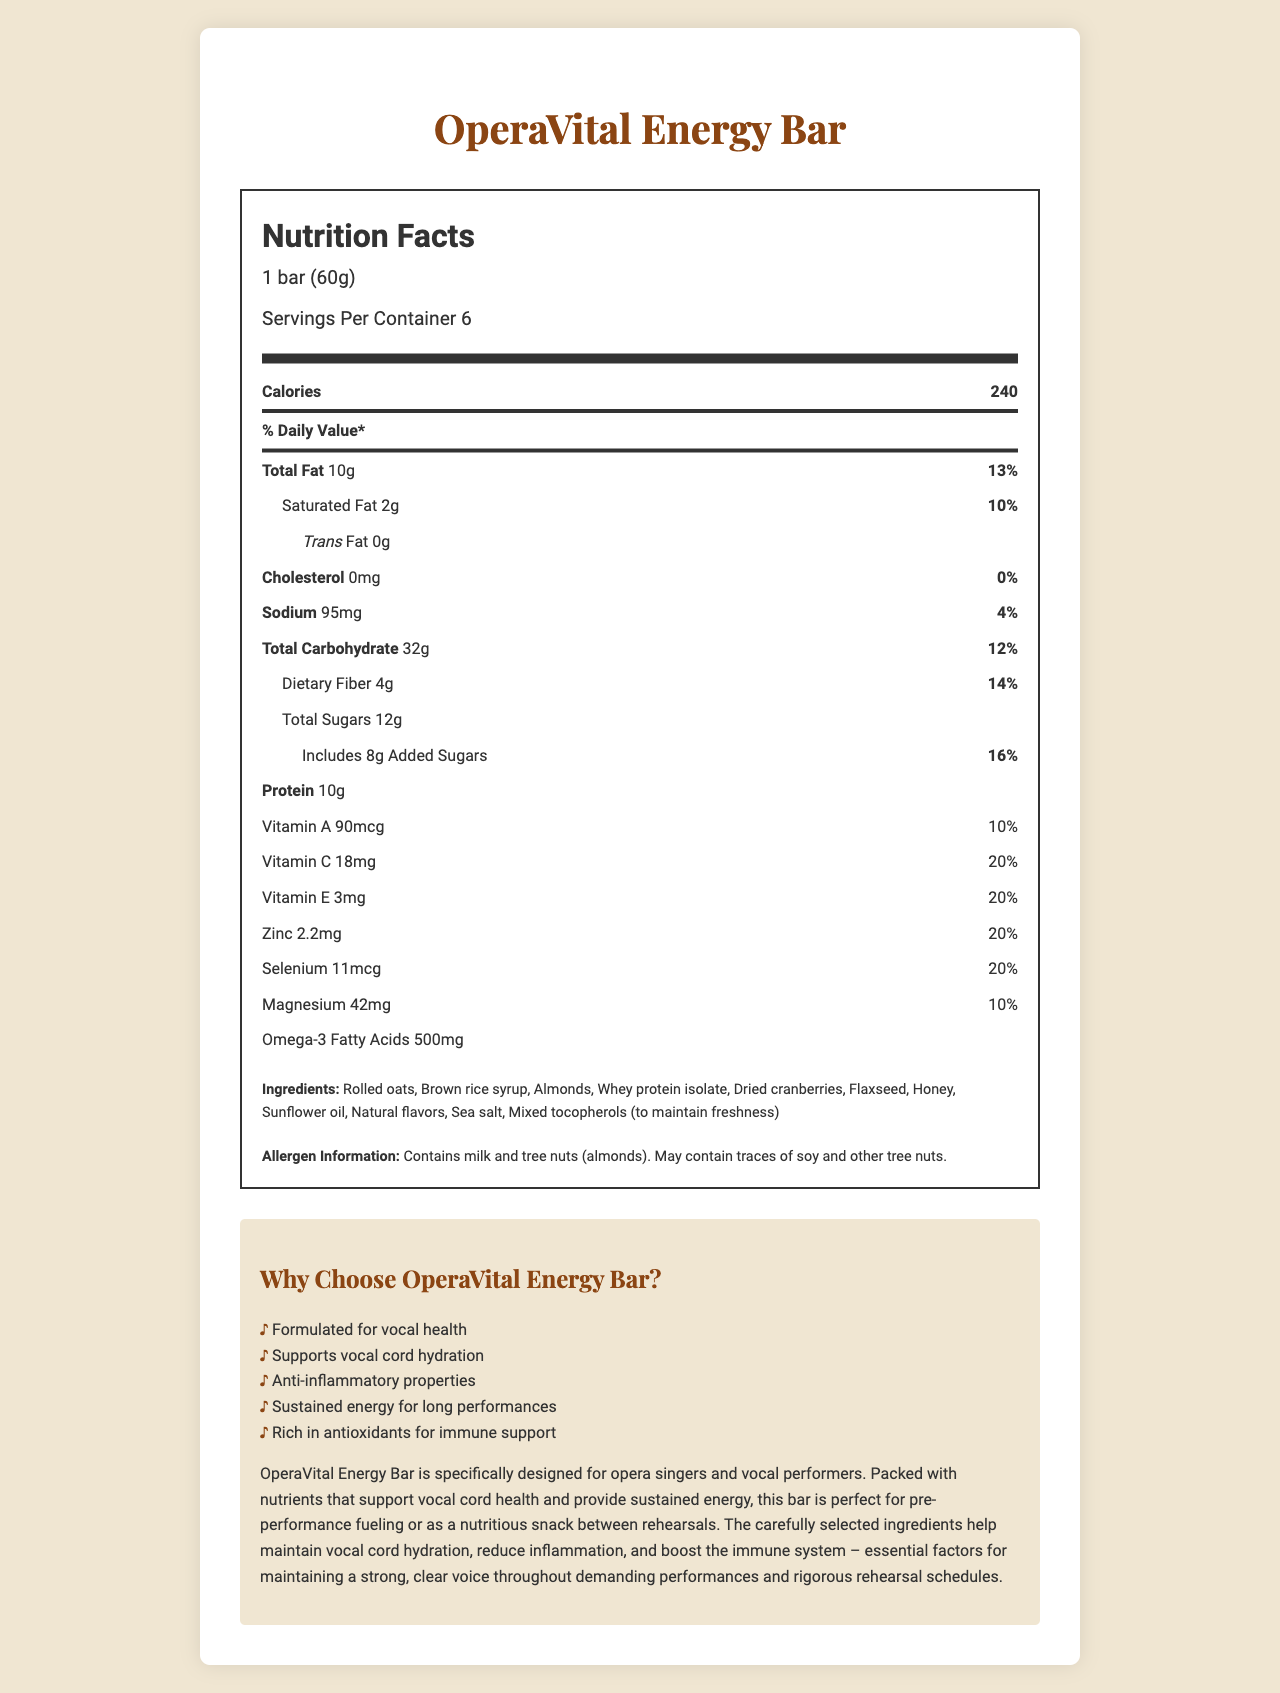what is the product name? The product name is clearly stated at the top of the document under the heading "OperaVital Energy Bar."
Answer: OperaVital Energy Bar how many servings are in one container? The document states "Servings Per Container 6" just below the serving size and calories section.
Answer: 6 how much protein does one bar contain? The amount of protein is listed in the nutrition facts section as "Protein 10g."
Answer: 10g what is the main marketing claim of the product? The first bullet point in the marketing claims section states "Formulated for vocal health."
Answer: Formulated for vocal health what ingredient may contain traces of soy? The document only mentions that the product "may contain traces of soy" but does not specify which ingredient in particular.
Answer: I don't know which vitamin has the highest daily value percentage in one serving: Vitamin A, Vitamin C, or Vitamin E? A. Vitamin A B. Vitamin C C. Vitamin E Vitamin C has a daily value percentage of 20%, which is higher than Vitamin A (10%) and Vitamin E (20%).
Answer: B how many calories are in one bar? The document lists the calories content as "Calories 240" under the nutrition facts section.
Answer: 240 contains this product tree nuts? (Yes/No) The allergen information clearly states "Contains milk and tree nuts (almonds)."
Answer: Yes which nutrient is specifically highlighted for its anti-inflammatory properties in the marketing claims? A. Omega-3 Fatty Acids B. Zinc C. Magnesium The marketing claims section mentions "Anti-inflammatory properties" as one of the benefits, which relates to Omega-3 Fatty Acids known for such properties.
Answer: A what is the serving size for the OperaVital Energy Bar? The serving size is listed as "1 bar (60g)" in the nutrition facts section.
Answer: 1 bar (60g) summarize the purpose and nutritional benefits of the OperaVital Energy Bar. The document explains that the OperaVital Energy Bar is tailored for vocalists, offering nutritional benefits such as vocal cord support, sustained energy, hydration, reduced inflammation, and immune support, making it ideal for pre-performance and rehearsal needs.
Answer: The OperaVital Energy Bar is specifically designed for opera singers and vocal performers. It provides nutrients that support vocal cord health, sustain energy, and maintain vocal cord hydration. The bar has anti-inflammatory properties and is rich in antioxidants to support the immune system. can the exact amount of each ingredient be determined from the document? The document lists the ingredients but does not provide specific quantities for each.
Answer: No 